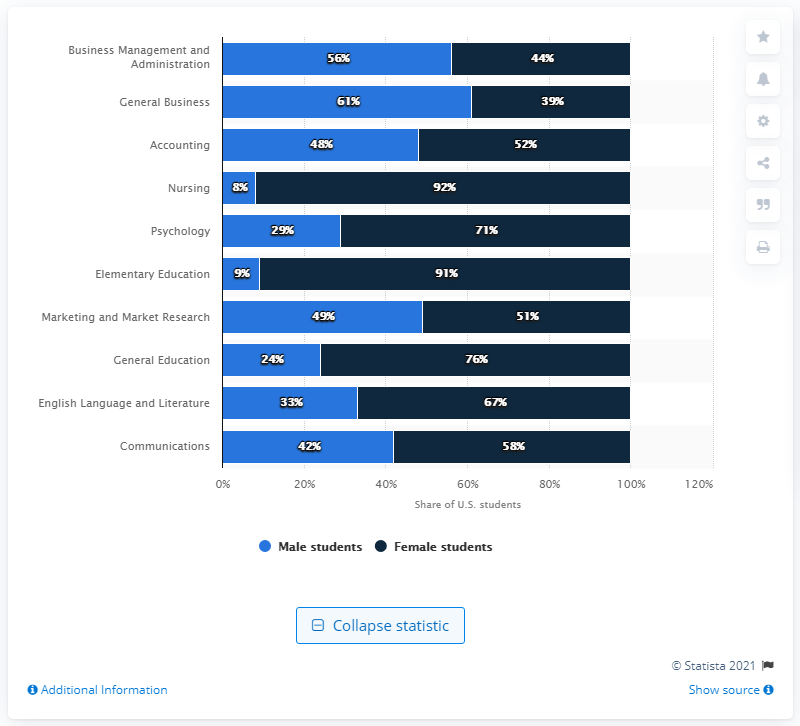Highlight a few significant elements in this photo. In the year 2009, Business Management and Administration was the most popular college major among students in the United States. 